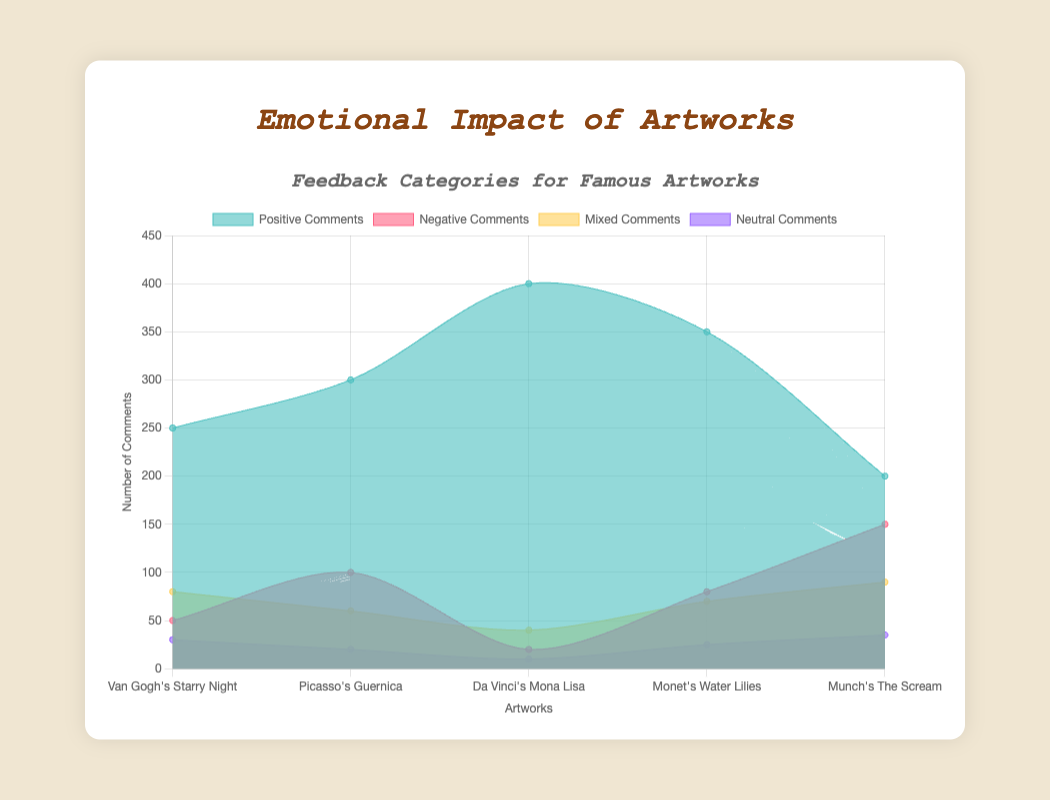What is the title of the figure? The title is displayed at the top of the chart, indicating what the chart is about.
Answer: Emotional Impact of Artworks What are the categories of feedback represented? The chart legend and labels show four categories of feedback: Positive Comments, Negative Comments, Mixed Comments, and Neutral Comments.
Answer: Positive Comments, Negative Comments, Mixed Comments, Neutral Comments Which artwork received the highest number of positive comments? By looking at the data for Positive Comments, Da Vinci's Mona Lisa has the highest value at 400.
Answer: Da Vinci's Mona Lisa How many artworks received more than 300 positive comments? The chart shows that Picasso's Guernica (300), Da Vinci's Mona Lisa (400), and Monet's Water Lilies (350) each received more than 300 positive comments.
Answer: 3 artworks Which artwork has the most negative comments? According to the data for Negative Comments, Munch's The Scream received the highest number with 150.
Answer: Munch's The Scream Compare the number of positive and negative comments for Van Gogh's Starry Night. Is the difference more than 200? Van Gogh's Starry Night has 250 positive comments and 50 negative comments. The difference is 250 - 50 = 200.
Answer: No What is the total number of neutral comments across all artworks? Summing the neutral comments for all artworks: 30 + 20 + 10 + 25 + 35 = 120.
Answer: 120 Which artwork has the highest total number of comments of all types combined? Summing all types of comments for each artwork and comparing them, Da Vinci's Mona Lisa has the highest total: 400 (Positive) + 20 (Negative) + 40 (Mixed) + 10 (Neutral) = 470.
Answer: Da Vinci's Mona Lisa Among the artworks, which has the smallest difference between positive and negative comments? Calculate the differences: 
- Starry Night: 250 - 50 = 200
- Guernica: 300 - 100 = 200
- Mona Lisa: 400 - 20 = 380
- Water Lilies: 350 - 80 = 270
- The Scream: 200 - 150 = 50
The smallest difference is for The Scream with 50.
Answer: Munch's The Scream Is there any artwork where the number of mixed comments is greater than the number of negative comments? Comparing each artwork:
- Starry Night: 80 (Mixed) > 50 (Negative)
- Guernica: 60 (Mixed) < 100 (Negative)
- Mona Lisa: 40 (Mixed) > 20 (Negative)
- Water Lilies: 70 (Mixed) < 80 (Negative)
- The Scream: 90 (Mixed) < 150 (Negative)
Starry Night and Mona Lisa have more mixed than negative comments.
Answer: Yes, 2 artworks 